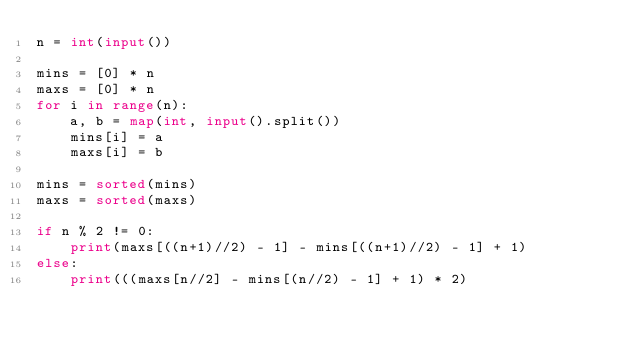<code> <loc_0><loc_0><loc_500><loc_500><_Python_>n = int(input())

mins = [0] * n
maxs = [0] * n
for i in range(n):
    a, b = map(int, input().split())
    mins[i] = a
    maxs[i] = b

mins = sorted(mins)
maxs = sorted(maxs)

if n % 2 != 0:
    print(maxs[((n+1)//2) - 1] - mins[((n+1)//2) - 1] + 1)
else:
    print(((maxs[n//2] - mins[(n//2) - 1] + 1) * 2)</code> 